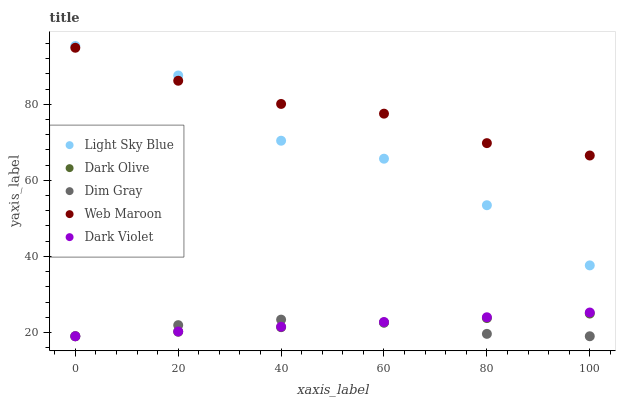Does Dim Gray have the minimum area under the curve?
Answer yes or no. Yes. Does Web Maroon have the maximum area under the curve?
Answer yes or no. Yes. Does Light Sky Blue have the minimum area under the curve?
Answer yes or no. No. Does Light Sky Blue have the maximum area under the curve?
Answer yes or no. No. Is Dark Violet the smoothest?
Answer yes or no. Yes. Is Light Sky Blue the roughest?
Answer yes or no. Yes. Is Dim Gray the smoothest?
Answer yes or no. No. Is Dim Gray the roughest?
Answer yes or no. No. Does Dark Olive have the lowest value?
Answer yes or no. Yes. Does Light Sky Blue have the lowest value?
Answer yes or no. No. Does Light Sky Blue have the highest value?
Answer yes or no. Yes. Does Dim Gray have the highest value?
Answer yes or no. No. Is Dark Olive less than Light Sky Blue?
Answer yes or no. Yes. Is Web Maroon greater than Dark Olive?
Answer yes or no. Yes. Does Dark Olive intersect Dim Gray?
Answer yes or no. Yes. Is Dark Olive less than Dim Gray?
Answer yes or no. No. Is Dark Olive greater than Dim Gray?
Answer yes or no. No. Does Dark Olive intersect Light Sky Blue?
Answer yes or no. No. 